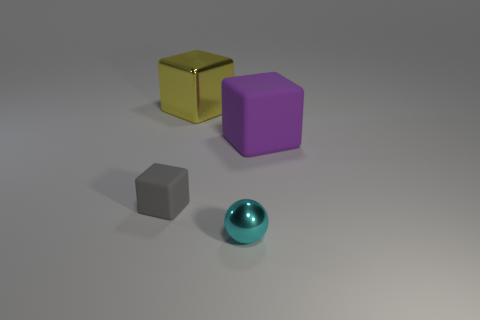What material is the gray object?
Keep it short and to the point. Rubber. Is the material of the large object behind the purple object the same as the big purple block?
Make the answer very short. No. What shape is the object left of the big shiny object?
Your answer should be compact. Cube. There is a object that is the same size as the sphere; what material is it?
Ensure brevity in your answer.  Rubber. How many objects are either tiny objects that are to the left of the large metallic object or cubes behind the big purple matte object?
Give a very brief answer. 2. There is a cyan object that is the same material as the large yellow cube; what size is it?
Offer a very short reply. Small. What number of metallic objects are yellow objects or small gray things?
Provide a short and direct response. 1. The gray thing has what size?
Your response must be concise. Small. Is the size of the purple object the same as the shiny sphere?
Your answer should be compact. No. What is the material of the large block that is behind the big purple matte object?
Your response must be concise. Metal. 